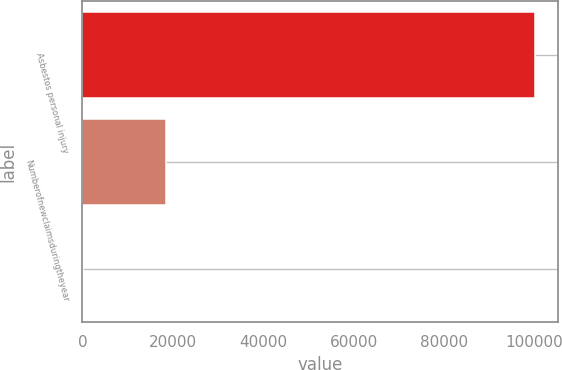<chart> <loc_0><loc_0><loc_500><loc_500><bar_chart><fcel>Asbestos personal injury<fcel>Numberofnewclaimsduringtheyear<fcel>Unnamed: 2<nl><fcel>100250<fcel>18500<fcel>74.3<nl></chart> 